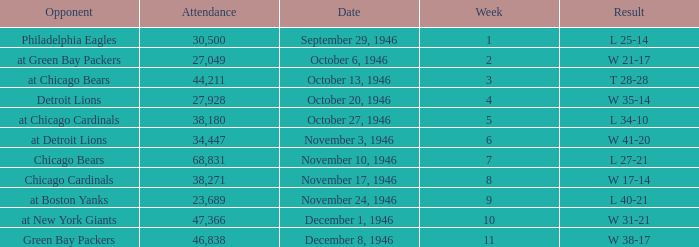What is the combined attendance of all games that had a result of w 35-14? 27928.0. 